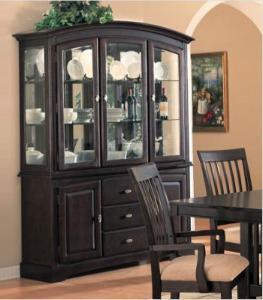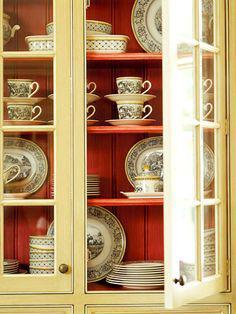The first image is the image on the left, the second image is the image on the right. Assess this claim about the two images: "One image shows a filled cabinet with at least one open paned glass door.". Correct or not? Answer yes or no. Yes. The first image is the image on the left, the second image is the image on the right. Evaluate the accuracy of this statement regarding the images: "At least two lights are seen at the top of the interior of a china cabinet.". Is it true? Answer yes or no. No. 